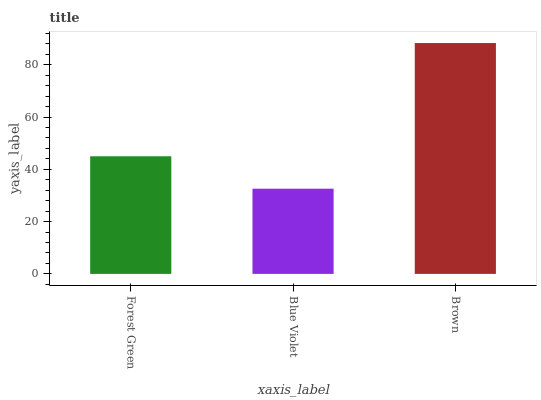Is Blue Violet the minimum?
Answer yes or no. Yes. Is Brown the maximum?
Answer yes or no. Yes. Is Brown the minimum?
Answer yes or no. No. Is Blue Violet the maximum?
Answer yes or no. No. Is Brown greater than Blue Violet?
Answer yes or no. Yes. Is Blue Violet less than Brown?
Answer yes or no. Yes. Is Blue Violet greater than Brown?
Answer yes or no. No. Is Brown less than Blue Violet?
Answer yes or no. No. Is Forest Green the high median?
Answer yes or no. Yes. Is Forest Green the low median?
Answer yes or no. Yes. Is Brown the high median?
Answer yes or no. No. Is Blue Violet the low median?
Answer yes or no. No. 